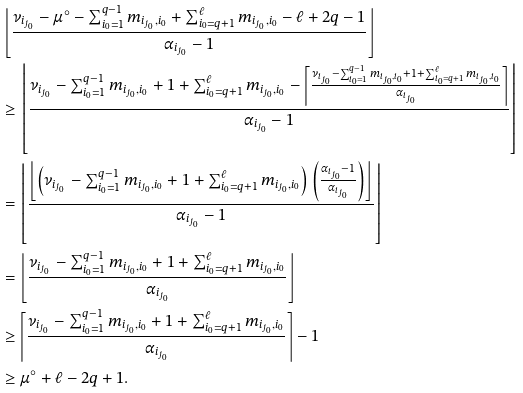Convert formula to latex. <formula><loc_0><loc_0><loc_500><loc_500>& \left \lfloor \frac { \nu _ { i _ { j _ { 0 } } } - \mu ^ { \circ } - \sum _ { i _ { 0 } = 1 } ^ { q - 1 } m _ { i _ { j _ { 0 } } , i _ { 0 } } + \sum _ { i _ { 0 } = q + 1 } ^ { \ell } m _ { i _ { j _ { 0 } } , i _ { 0 } } - \ell + 2 q - 1 } { \alpha _ { i _ { j _ { 0 } } } - 1 } \right \rfloor \\ & \geq \left \lfloor \frac { \nu _ { i _ { j _ { 0 } } } - \sum _ { i _ { 0 } = 1 } ^ { q - 1 } m _ { i _ { j _ { 0 } } , i _ { 0 } } + 1 + \sum _ { i _ { 0 } = q + 1 } ^ { \ell } m _ { i _ { j _ { 0 } } , i _ { 0 } } - \left \lceil \frac { \nu _ { i _ { j _ { 0 } } } - \sum _ { i _ { 0 } = 1 } ^ { q - 1 } m _ { i _ { j _ { 0 } } , i _ { 0 } } + 1 + \sum _ { i _ { 0 } = q + 1 } ^ { \ell } m _ { i _ { j _ { 0 } } , i _ { 0 } } } { \alpha _ { i _ { j _ { 0 } } } } \right \rceil } { \alpha _ { i _ { j _ { 0 } } } - 1 } \right \rfloor \\ & = \left \lfloor \frac { \left \lfloor \left ( \nu _ { i _ { j _ { 0 } } } - \sum _ { i _ { 0 } = 1 } ^ { q - 1 } m _ { i _ { j _ { 0 } } , i _ { 0 } } + 1 + \sum _ { i _ { 0 } = q + 1 } ^ { \ell } m _ { i _ { j _ { 0 } } , i _ { 0 } } \right ) \left ( \frac { \alpha _ { i _ { j _ { 0 } } } - 1 } { \alpha _ { i _ { j _ { 0 } } } } \right ) \right \rfloor } { \alpha _ { i _ { j _ { 0 } } } - 1 } \right \rfloor \\ & = \left \lfloor \frac { \nu _ { i _ { j _ { 0 } } } - \sum _ { i _ { 0 } = 1 } ^ { q - 1 } m _ { i _ { j _ { 0 } } , i _ { 0 } } + 1 + \sum _ { i _ { 0 } = q + 1 } ^ { \ell } m _ { i _ { j _ { 0 } } , i _ { 0 } } } { \alpha _ { i _ { j _ { 0 } } } } \right \rfloor \\ & \geq \left \lceil \frac { \nu _ { i _ { j _ { 0 } } } - \sum _ { i _ { 0 } = 1 } ^ { q - 1 } m _ { i _ { j _ { 0 } } , i _ { 0 } } + 1 + \sum _ { i _ { 0 } = q + 1 } ^ { \ell } m _ { i _ { j _ { 0 } } , i _ { 0 } } } { \alpha _ { i _ { j _ { 0 } } } } \right \rceil - 1 \\ & \geq \mu ^ { \circ } + \ell - 2 q + 1 .</formula> 